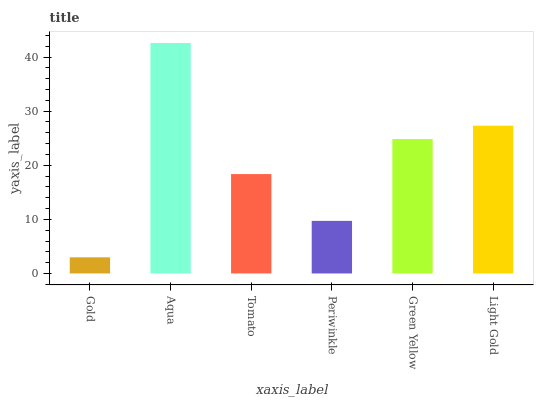Is Gold the minimum?
Answer yes or no. Yes. Is Aqua the maximum?
Answer yes or no. Yes. Is Tomato the minimum?
Answer yes or no. No. Is Tomato the maximum?
Answer yes or no. No. Is Aqua greater than Tomato?
Answer yes or no. Yes. Is Tomato less than Aqua?
Answer yes or no. Yes. Is Tomato greater than Aqua?
Answer yes or no. No. Is Aqua less than Tomato?
Answer yes or no. No. Is Green Yellow the high median?
Answer yes or no. Yes. Is Tomato the low median?
Answer yes or no. Yes. Is Tomato the high median?
Answer yes or no. No. Is Periwinkle the low median?
Answer yes or no. No. 